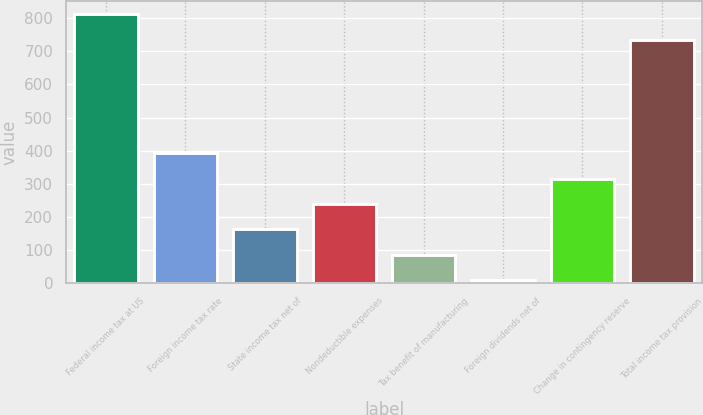<chart> <loc_0><loc_0><loc_500><loc_500><bar_chart><fcel>Federal income tax at US<fcel>Foreign income tax rate<fcel>State income tax net of<fcel>Nondeductible expenses<fcel>Tax benefit of manufacturing<fcel>Foreign dividends net of<fcel>Change in contingency reserve<fcel>Total income tax provision<nl><fcel>811.3<fcel>391.5<fcel>162.6<fcel>238.9<fcel>86.3<fcel>10<fcel>315.2<fcel>735<nl></chart> 